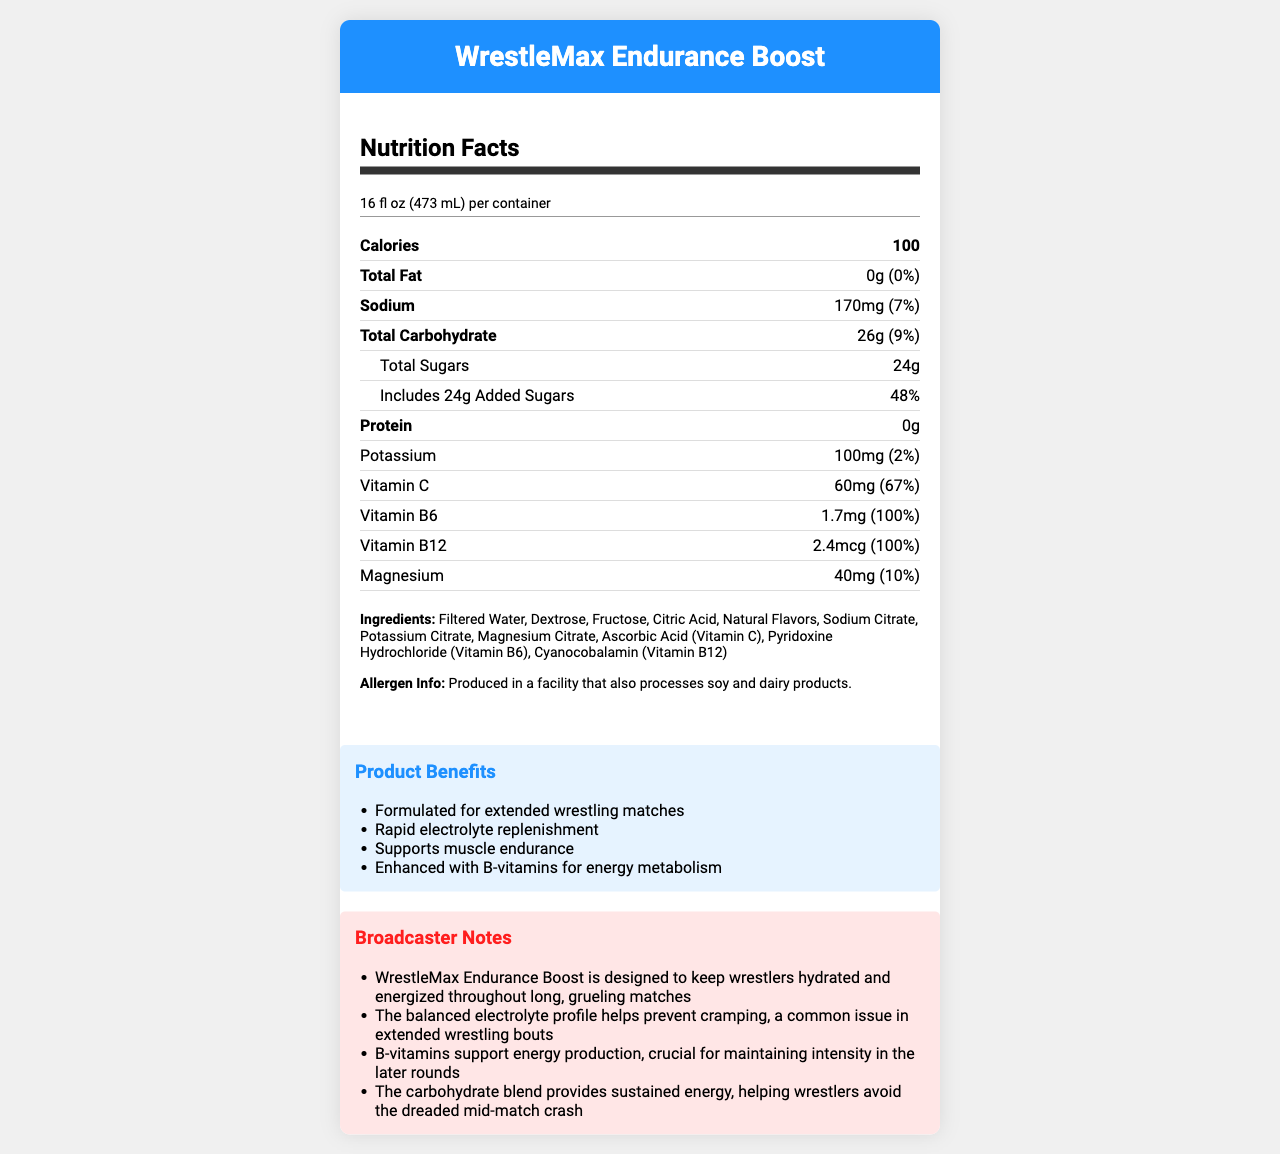what is the serving size of WrestleMax Endurance Boost? The serving size is stated at the top of the nutrition facts section as "16 fl oz (473 mL)".
Answer: 16 fl oz (473 mL) how many calories are in one serving? The number of calories per serving is listed as "100" in the nutrition facts section.
Answer: 100 what percentage of the daily value for added sugars does one serving of WrestleMax Endurance Boost contain? The daily value percentage for added sugars is listed as "48%" in the nutrition facts section.
Answer: 48% list three ingredients found in WrestleMax Endurance Boost. The ingredients list includes "Filtered Water, Dextrose, Fructose" among other ingredients.
Answer: Filtered Water, Dextrose, Fructose which vitamins are present at 100% of the daily value in one serving? Both Vitamin B6 and Vitamin B12 have daily values listed as 100% in the nutrition facts section.
Answer: Vitamin B6, Vitamin B12 how much potassium is in one serving? The potassium content per serving is listed as "100mg" in the nutrition facts section.
Answer: 100mg are there any allergens in WrestleMax Endurance Boost? The allergen information states it is produced in a facility that processes soy and dairy products.
Answer: Produced in a facility that also processes soy and dairy products. what is the marketing claim related to electrolyte replenishment? One of the marketing claims listed is "Rapid electrolyte replenishment".
Answer: Rapid electrolyte replenishment how many grams of total carbohydrate are in one serving? The total carbohydrate content per serving is listed as "26g".
Answer: 26g what is the amount of magnesium in one serving? The amount of magnesium per serving is listed as "40mg" in the nutrition facts section.
Answer: 40mg what is the main purpose of WrestleMax Endurance Boost as described in the broadcaster notes? The main purpose is described as keeping wrestlers hydrated and energized throughout long matches.
Answer: Designed to keep wrestlers hydrated and energized throughout long, grueling matches which of the following is NOT an ingredient in WrestleMax Endurance Boost? A. Sodium Citrate B. Magnesium Citrate C. High Fructose Corn Syrup D. Ascorbic Acid High Fructose Corn Syrup is not listed among the ingredients.
Answer: C. High Fructose Corn Syrup how many servings per container does WrestleMax Endurance Boost have? A. 1 B. 2 C. 3 D. 4 The servings per container is listed as "1" in the nutrition facts section.
Answer: A. 1 does WrestleMax Endurance Boost contain any protein? The protein content is listed as "0g", indicating that there is no protein in the drink.
Answer: No summarize the main nutritional and marketing information of WrestleMax Endurance Boost. The product is designed to help wrestlers stay hydrated and maintain energy levels during long matches, providing a balanced nutrient profile to prevent cramping and support muscle endurance.
Answer: WrestleMax Endurance Boost is a sports drink designed for extended wrestling matches. It contains 100 calories per 16 fl oz serving, with notable quantities of sodium, carbohydrates, sugars, potassium, vitamin C, vitamin B6, vitamin B12, and magnesium. It is marketed for rapid electrolyte replenishment, muscle endurance support, and energy metabolism enhancement. how many types of B vitamins are listed in the nutrition facts? The document lists Vitamin B6 and Vitamin B12 as the B vitamins present.
Answer: Two can the document determine if WrestleMax Endurance Boost is suitable for someone with a soy allergy? The label mentions it is produced in a facility that processes soy, but does not specify if it is completely free from soy allergens.
Answer: Cannot be determined 